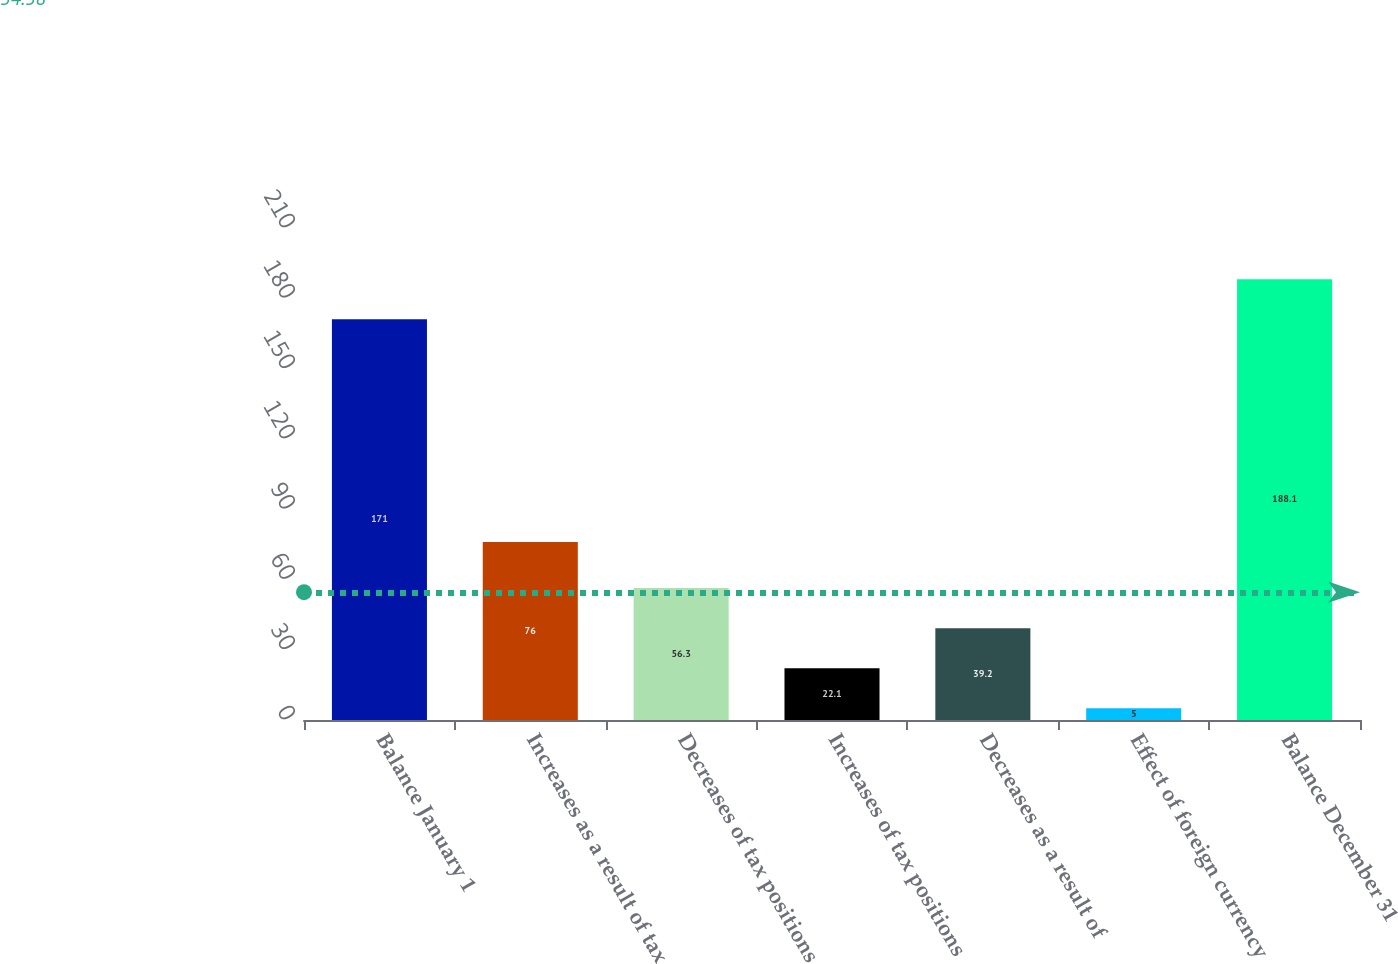<chart> <loc_0><loc_0><loc_500><loc_500><bar_chart><fcel>Balance January 1<fcel>Increases as a result of tax<fcel>Decreases of tax positions<fcel>Increases of tax positions<fcel>Decreases as a result of<fcel>Effect of foreign currency<fcel>Balance December 31<nl><fcel>171<fcel>76<fcel>56.3<fcel>22.1<fcel>39.2<fcel>5<fcel>188.1<nl></chart> 